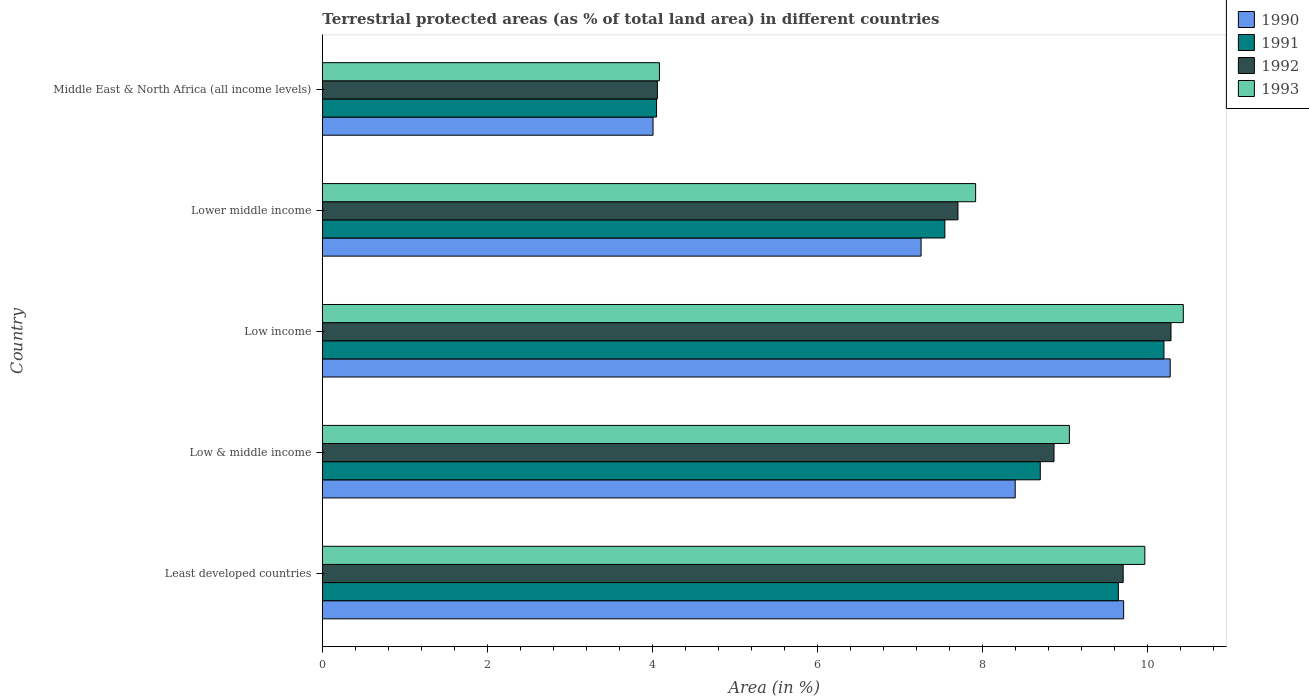How many groups of bars are there?
Provide a short and direct response. 5. Are the number of bars on each tick of the Y-axis equal?
Provide a succinct answer. Yes. What is the label of the 4th group of bars from the top?
Ensure brevity in your answer.  Low & middle income. In how many cases, is the number of bars for a given country not equal to the number of legend labels?
Make the answer very short. 0. What is the percentage of terrestrial protected land in 1992 in Middle East & North Africa (all income levels)?
Ensure brevity in your answer.  4.06. Across all countries, what is the maximum percentage of terrestrial protected land in 1990?
Your response must be concise. 10.27. Across all countries, what is the minimum percentage of terrestrial protected land in 1990?
Provide a succinct answer. 4.01. In which country was the percentage of terrestrial protected land in 1992 maximum?
Offer a very short reply. Low income. In which country was the percentage of terrestrial protected land in 1991 minimum?
Your answer should be compact. Middle East & North Africa (all income levels). What is the total percentage of terrestrial protected land in 1991 in the graph?
Ensure brevity in your answer.  40.14. What is the difference between the percentage of terrestrial protected land in 1990 in Least developed countries and that in Middle East & North Africa (all income levels)?
Make the answer very short. 5.7. What is the difference between the percentage of terrestrial protected land in 1992 in Middle East & North Africa (all income levels) and the percentage of terrestrial protected land in 1993 in Low income?
Give a very brief answer. -6.37. What is the average percentage of terrestrial protected land in 1993 per country?
Your response must be concise. 8.29. What is the difference between the percentage of terrestrial protected land in 1991 and percentage of terrestrial protected land in 1990 in Middle East & North Africa (all income levels)?
Your response must be concise. 0.04. In how many countries, is the percentage of terrestrial protected land in 1990 greater than 4.8 %?
Keep it short and to the point. 4. What is the ratio of the percentage of terrestrial protected land in 1990 in Least developed countries to that in Middle East & North Africa (all income levels)?
Provide a short and direct response. 2.42. Is the difference between the percentage of terrestrial protected land in 1991 in Low income and Middle East & North Africa (all income levels) greater than the difference between the percentage of terrestrial protected land in 1990 in Low income and Middle East & North Africa (all income levels)?
Make the answer very short. No. What is the difference between the highest and the second highest percentage of terrestrial protected land in 1990?
Offer a very short reply. 0.56. What is the difference between the highest and the lowest percentage of terrestrial protected land in 1991?
Your answer should be compact. 6.15. Is the sum of the percentage of terrestrial protected land in 1993 in Low & middle income and Low income greater than the maximum percentage of terrestrial protected land in 1991 across all countries?
Make the answer very short. Yes. What does the 1st bar from the top in Low income represents?
Your response must be concise. 1993. What does the 3rd bar from the bottom in Low & middle income represents?
Offer a very short reply. 1992. Is it the case that in every country, the sum of the percentage of terrestrial protected land in 1993 and percentage of terrestrial protected land in 1990 is greater than the percentage of terrestrial protected land in 1991?
Offer a very short reply. Yes. How many bars are there?
Make the answer very short. 20. Are all the bars in the graph horizontal?
Make the answer very short. Yes. What is the difference between two consecutive major ticks on the X-axis?
Give a very brief answer. 2. Does the graph contain any zero values?
Ensure brevity in your answer.  No. Where does the legend appear in the graph?
Keep it short and to the point. Top right. How are the legend labels stacked?
Offer a very short reply. Vertical. What is the title of the graph?
Make the answer very short. Terrestrial protected areas (as % of total land area) in different countries. What is the label or title of the X-axis?
Provide a short and direct response. Area (in %). What is the label or title of the Y-axis?
Make the answer very short. Country. What is the Area (in %) of 1990 in Least developed countries?
Make the answer very short. 9.71. What is the Area (in %) of 1991 in Least developed countries?
Provide a succinct answer. 9.65. What is the Area (in %) in 1992 in Least developed countries?
Your answer should be very brief. 9.7. What is the Area (in %) of 1993 in Least developed countries?
Keep it short and to the point. 9.97. What is the Area (in %) of 1990 in Low & middle income?
Your answer should be compact. 8.4. What is the Area (in %) of 1991 in Low & middle income?
Give a very brief answer. 8.7. What is the Area (in %) in 1992 in Low & middle income?
Provide a short and direct response. 8.87. What is the Area (in %) in 1993 in Low & middle income?
Your response must be concise. 9.05. What is the Area (in %) in 1990 in Low income?
Offer a terse response. 10.27. What is the Area (in %) in 1991 in Low income?
Your answer should be very brief. 10.2. What is the Area (in %) in 1992 in Low income?
Ensure brevity in your answer.  10.28. What is the Area (in %) in 1993 in Low income?
Your response must be concise. 10.43. What is the Area (in %) of 1990 in Lower middle income?
Your answer should be compact. 7.26. What is the Area (in %) of 1991 in Lower middle income?
Give a very brief answer. 7.54. What is the Area (in %) in 1992 in Lower middle income?
Your response must be concise. 7.7. What is the Area (in %) of 1993 in Lower middle income?
Make the answer very short. 7.92. What is the Area (in %) of 1990 in Middle East & North Africa (all income levels)?
Provide a succinct answer. 4.01. What is the Area (in %) of 1991 in Middle East & North Africa (all income levels)?
Offer a very short reply. 4.05. What is the Area (in %) of 1992 in Middle East & North Africa (all income levels)?
Make the answer very short. 4.06. What is the Area (in %) of 1993 in Middle East & North Africa (all income levels)?
Make the answer very short. 4.08. Across all countries, what is the maximum Area (in %) in 1990?
Your response must be concise. 10.27. Across all countries, what is the maximum Area (in %) of 1991?
Your answer should be very brief. 10.2. Across all countries, what is the maximum Area (in %) in 1992?
Provide a succinct answer. 10.28. Across all countries, what is the maximum Area (in %) in 1993?
Give a very brief answer. 10.43. Across all countries, what is the minimum Area (in %) of 1990?
Offer a very short reply. 4.01. Across all countries, what is the minimum Area (in %) in 1991?
Your answer should be very brief. 4.05. Across all countries, what is the minimum Area (in %) in 1992?
Offer a terse response. 4.06. Across all countries, what is the minimum Area (in %) in 1993?
Keep it short and to the point. 4.08. What is the total Area (in %) of 1990 in the graph?
Offer a very short reply. 39.64. What is the total Area (in %) of 1991 in the graph?
Your response must be concise. 40.14. What is the total Area (in %) of 1992 in the graph?
Make the answer very short. 40.62. What is the total Area (in %) of 1993 in the graph?
Your response must be concise. 41.45. What is the difference between the Area (in %) of 1990 in Least developed countries and that in Low & middle income?
Provide a succinct answer. 1.31. What is the difference between the Area (in %) of 1991 in Least developed countries and that in Low & middle income?
Keep it short and to the point. 0.95. What is the difference between the Area (in %) of 1992 in Least developed countries and that in Low & middle income?
Offer a terse response. 0.84. What is the difference between the Area (in %) in 1993 in Least developed countries and that in Low & middle income?
Your answer should be compact. 0.91. What is the difference between the Area (in %) in 1990 in Least developed countries and that in Low income?
Your answer should be very brief. -0.56. What is the difference between the Area (in %) in 1991 in Least developed countries and that in Low income?
Offer a very short reply. -0.55. What is the difference between the Area (in %) of 1992 in Least developed countries and that in Low income?
Provide a succinct answer. -0.58. What is the difference between the Area (in %) in 1993 in Least developed countries and that in Low income?
Provide a succinct answer. -0.47. What is the difference between the Area (in %) of 1990 in Least developed countries and that in Lower middle income?
Provide a short and direct response. 2.45. What is the difference between the Area (in %) of 1991 in Least developed countries and that in Lower middle income?
Keep it short and to the point. 2.1. What is the difference between the Area (in %) in 1992 in Least developed countries and that in Lower middle income?
Your response must be concise. 2. What is the difference between the Area (in %) of 1993 in Least developed countries and that in Lower middle income?
Provide a short and direct response. 2.05. What is the difference between the Area (in %) in 1990 in Least developed countries and that in Middle East & North Africa (all income levels)?
Give a very brief answer. 5.7. What is the difference between the Area (in %) of 1991 in Least developed countries and that in Middle East & North Africa (all income levels)?
Keep it short and to the point. 5.6. What is the difference between the Area (in %) of 1992 in Least developed countries and that in Middle East & North Africa (all income levels)?
Offer a terse response. 5.64. What is the difference between the Area (in %) in 1993 in Least developed countries and that in Middle East & North Africa (all income levels)?
Keep it short and to the point. 5.88. What is the difference between the Area (in %) of 1990 in Low & middle income and that in Low income?
Your answer should be very brief. -1.88. What is the difference between the Area (in %) in 1991 in Low & middle income and that in Low income?
Make the answer very short. -1.5. What is the difference between the Area (in %) of 1992 in Low & middle income and that in Low income?
Provide a short and direct response. -1.42. What is the difference between the Area (in %) of 1993 in Low & middle income and that in Low income?
Keep it short and to the point. -1.38. What is the difference between the Area (in %) of 1990 in Low & middle income and that in Lower middle income?
Make the answer very short. 1.14. What is the difference between the Area (in %) in 1991 in Low & middle income and that in Lower middle income?
Offer a terse response. 1.16. What is the difference between the Area (in %) in 1992 in Low & middle income and that in Lower middle income?
Keep it short and to the point. 1.16. What is the difference between the Area (in %) of 1993 in Low & middle income and that in Lower middle income?
Offer a very short reply. 1.14. What is the difference between the Area (in %) in 1990 in Low & middle income and that in Middle East & North Africa (all income levels)?
Your response must be concise. 4.39. What is the difference between the Area (in %) in 1991 in Low & middle income and that in Middle East & North Africa (all income levels)?
Your answer should be compact. 4.65. What is the difference between the Area (in %) in 1992 in Low & middle income and that in Middle East & North Africa (all income levels)?
Offer a terse response. 4.81. What is the difference between the Area (in %) in 1993 in Low & middle income and that in Middle East & North Africa (all income levels)?
Offer a terse response. 4.97. What is the difference between the Area (in %) of 1990 in Low income and that in Lower middle income?
Offer a terse response. 3.02. What is the difference between the Area (in %) in 1991 in Low income and that in Lower middle income?
Ensure brevity in your answer.  2.65. What is the difference between the Area (in %) in 1992 in Low income and that in Lower middle income?
Offer a terse response. 2.58. What is the difference between the Area (in %) of 1993 in Low income and that in Lower middle income?
Provide a succinct answer. 2.52. What is the difference between the Area (in %) of 1990 in Low income and that in Middle East & North Africa (all income levels)?
Offer a very short reply. 6.27. What is the difference between the Area (in %) in 1991 in Low income and that in Middle East & North Africa (all income levels)?
Your response must be concise. 6.15. What is the difference between the Area (in %) of 1992 in Low income and that in Middle East & North Africa (all income levels)?
Make the answer very short. 6.22. What is the difference between the Area (in %) in 1993 in Low income and that in Middle East & North Africa (all income levels)?
Ensure brevity in your answer.  6.35. What is the difference between the Area (in %) of 1990 in Lower middle income and that in Middle East & North Africa (all income levels)?
Provide a short and direct response. 3.25. What is the difference between the Area (in %) of 1991 in Lower middle income and that in Middle East & North Africa (all income levels)?
Ensure brevity in your answer.  3.49. What is the difference between the Area (in %) in 1992 in Lower middle income and that in Middle East & North Africa (all income levels)?
Your answer should be very brief. 3.64. What is the difference between the Area (in %) in 1993 in Lower middle income and that in Middle East & North Africa (all income levels)?
Offer a very short reply. 3.83. What is the difference between the Area (in %) in 1990 in Least developed countries and the Area (in %) in 1991 in Low & middle income?
Your answer should be very brief. 1.01. What is the difference between the Area (in %) in 1990 in Least developed countries and the Area (in %) in 1992 in Low & middle income?
Your answer should be compact. 0.84. What is the difference between the Area (in %) of 1990 in Least developed countries and the Area (in %) of 1993 in Low & middle income?
Provide a succinct answer. 0.66. What is the difference between the Area (in %) in 1991 in Least developed countries and the Area (in %) in 1992 in Low & middle income?
Provide a short and direct response. 0.78. What is the difference between the Area (in %) in 1991 in Least developed countries and the Area (in %) in 1993 in Low & middle income?
Your response must be concise. 0.59. What is the difference between the Area (in %) in 1992 in Least developed countries and the Area (in %) in 1993 in Low & middle income?
Make the answer very short. 0.65. What is the difference between the Area (in %) in 1990 in Least developed countries and the Area (in %) in 1991 in Low income?
Provide a short and direct response. -0.49. What is the difference between the Area (in %) in 1990 in Least developed countries and the Area (in %) in 1992 in Low income?
Provide a succinct answer. -0.57. What is the difference between the Area (in %) in 1990 in Least developed countries and the Area (in %) in 1993 in Low income?
Your answer should be very brief. -0.72. What is the difference between the Area (in %) in 1991 in Least developed countries and the Area (in %) in 1992 in Low income?
Your answer should be very brief. -0.64. What is the difference between the Area (in %) in 1991 in Least developed countries and the Area (in %) in 1993 in Low income?
Give a very brief answer. -0.79. What is the difference between the Area (in %) of 1992 in Least developed countries and the Area (in %) of 1993 in Low income?
Offer a terse response. -0.73. What is the difference between the Area (in %) of 1990 in Least developed countries and the Area (in %) of 1991 in Lower middle income?
Your answer should be very brief. 2.17. What is the difference between the Area (in %) of 1990 in Least developed countries and the Area (in %) of 1992 in Lower middle income?
Provide a short and direct response. 2.01. What is the difference between the Area (in %) in 1990 in Least developed countries and the Area (in %) in 1993 in Lower middle income?
Give a very brief answer. 1.79. What is the difference between the Area (in %) in 1991 in Least developed countries and the Area (in %) in 1992 in Lower middle income?
Your response must be concise. 1.94. What is the difference between the Area (in %) of 1991 in Least developed countries and the Area (in %) of 1993 in Lower middle income?
Your answer should be very brief. 1.73. What is the difference between the Area (in %) of 1992 in Least developed countries and the Area (in %) of 1993 in Lower middle income?
Offer a terse response. 1.79. What is the difference between the Area (in %) of 1990 in Least developed countries and the Area (in %) of 1991 in Middle East & North Africa (all income levels)?
Your answer should be very brief. 5.66. What is the difference between the Area (in %) in 1990 in Least developed countries and the Area (in %) in 1992 in Middle East & North Africa (all income levels)?
Ensure brevity in your answer.  5.65. What is the difference between the Area (in %) in 1990 in Least developed countries and the Area (in %) in 1993 in Middle East & North Africa (all income levels)?
Offer a terse response. 5.63. What is the difference between the Area (in %) in 1991 in Least developed countries and the Area (in %) in 1992 in Middle East & North Africa (all income levels)?
Offer a terse response. 5.59. What is the difference between the Area (in %) of 1991 in Least developed countries and the Area (in %) of 1993 in Middle East & North Africa (all income levels)?
Your answer should be compact. 5.56. What is the difference between the Area (in %) in 1992 in Least developed countries and the Area (in %) in 1993 in Middle East & North Africa (all income levels)?
Provide a short and direct response. 5.62. What is the difference between the Area (in %) of 1990 in Low & middle income and the Area (in %) of 1991 in Low income?
Ensure brevity in your answer.  -1.8. What is the difference between the Area (in %) of 1990 in Low & middle income and the Area (in %) of 1992 in Low income?
Your answer should be very brief. -1.89. What is the difference between the Area (in %) in 1990 in Low & middle income and the Area (in %) in 1993 in Low income?
Provide a succinct answer. -2.04. What is the difference between the Area (in %) of 1991 in Low & middle income and the Area (in %) of 1992 in Low income?
Offer a terse response. -1.58. What is the difference between the Area (in %) in 1991 in Low & middle income and the Area (in %) in 1993 in Low income?
Keep it short and to the point. -1.73. What is the difference between the Area (in %) of 1992 in Low & middle income and the Area (in %) of 1993 in Low income?
Your answer should be compact. -1.57. What is the difference between the Area (in %) in 1990 in Low & middle income and the Area (in %) in 1991 in Lower middle income?
Keep it short and to the point. 0.85. What is the difference between the Area (in %) in 1990 in Low & middle income and the Area (in %) in 1992 in Lower middle income?
Offer a very short reply. 0.69. What is the difference between the Area (in %) in 1990 in Low & middle income and the Area (in %) in 1993 in Lower middle income?
Provide a short and direct response. 0.48. What is the difference between the Area (in %) in 1991 in Low & middle income and the Area (in %) in 1992 in Lower middle income?
Your answer should be compact. 1. What is the difference between the Area (in %) in 1991 in Low & middle income and the Area (in %) in 1993 in Lower middle income?
Provide a succinct answer. 0.78. What is the difference between the Area (in %) in 1992 in Low & middle income and the Area (in %) in 1993 in Lower middle income?
Ensure brevity in your answer.  0.95. What is the difference between the Area (in %) of 1990 in Low & middle income and the Area (in %) of 1991 in Middle East & North Africa (all income levels)?
Offer a very short reply. 4.35. What is the difference between the Area (in %) of 1990 in Low & middle income and the Area (in %) of 1992 in Middle East & North Africa (all income levels)?
Offer a very short reply. 4.34. What is the difference between the Area (in %) in 1990 in Low & middle income and the Area (in %) in 1993 in Middle East & North Africa (all income levels)?
Your answer should be compact. 4.31. What is the difference between the Area (in %) in 1991 in Low & middle income and the Area (in %) in 1992 in Middle East & North Africa (all income levels)?
Ensure brevity in your answer.  4.64. What is the difference between the Area (in %) of 1991 in Low & middle income and the Area (in %) of 1993 in Middle East & North Africa (all income levels)?
Keep it short and to the point. 4.62. What is the difference between the Area (in %) of 1992 in Low & middle income and the Area (in %) of 1993 in Middle East & North Africa (all income levels)?
Ensure brevity in your answer.  4.78. What is the difference between the Area (in %) in 1990 in Low income and the Area (in %) in 1991 in Lower middle income?
Give a very brief answer. 2.73. What is the difference between the Area (in %) in 1990 in Low income and the Area (in %) in 1992 in Lower middle income?
Your response must be concise. 2.57. What is the difference between the Area (in %) of 1990 in Low income and the Area (in %) of 1993 in Lower middle income?
Give a very brief answer. 2.36. What is the difference between the Area (in %) in 1991 in Low income and the Area (in %) in 1992 in Lower middle income?
Your answer should be compact. 2.5. What is the difference between the Area (in %) in 1991 in Low income and the Area (in %) in 1993 in Lower middle income?
Your answer should be very brief. 2.28. What is the difference between the Area (in %) of 1992 in Low income and the Area (in %) of 1993 in Lower middle income?
Your response must be concise. 2.37. What is the difference between the Area (in %) of 1990 in Low income and the Area (in %) of 1991 in Middle East & North Africa (all income levels)?
Provide a succinct answer. 6.22. What is the difference between the Area (in %) in 1990 in Low income and the Area (in %) in 1992 in Middle East & North Africa (all income levels)?
Your answer should be very brief. 6.21. What is the difference between the Area (in %) in 1990 in Low income and the Area (in %) in 1993 in Middle East & North Africa (all income levels)?
Your answer should be very brief. 6.19. What is the difference between the Area (in %) of 1991 in Low income and the Area (in %) of 1992 in Middle East & North Africa (all income levels)?
Give a very brief answer. 6.14. What is the difference between the Area (in %) in 1991 in Low income and the Area (in %) in 1993 in Middle East & North Africa (all income levels)?
Give a very brief answer. 6.11. What is the difference between the Area (in %) in 1992 in Low income and the Area (in %) in 1993 in Middle East & North Africa (all income levels)?
Make the answer very short. 6.2. What is the difference between the Area (in %) of 1990 in Lower middle income and the Area (in %) of 1991 in Middle East & North Africa (all income levels)?
Provide a succinct answer. 3.21. What is the difference between the Area (in %) of 1990 in Lower middle income and the Area (in %) of 1992 in Middle East & North Africa (all income levels)?
Your answer should be compact. 3.2. What is the difference between the Area (in %) of 1990 in Lower middle income and the Area (in %) of 1993 in Middle East & North Africa (all income levels)?
Your response must be concise. 3.17. What is the difference between the Area (in %) in 1991 in Lower middle income and the Area (in %) in 1992 in Middle East & North Africa (all income levels)?
Ensure brevity in your answer.  3.48. What is the difference between the Area (in %) in 1991 in Lower middle income and the Area (in %) in 1993 in Middle East & North Africa (all income levels)?
Keep it short and to the point. 3.46. What is the difference between the Area (in %) in 1992 in Lower middle income and the Area (in %) in 1993 in Middle East & North Africa (all income levels)?
Ensure brevity in your answer.  3.62. What is the average Area (in %) of 1990 per country?
Provide a short and direct response. 7.93. What is the average Area (in %) of 1991 per country?
Provide a short and direct response. 8.03. What is the average Area (in %) of 1992 per country?
Your response must be concise. 8.12. What is the average Area (in %) in 1993 per country?
Your answer should be compact. 8.29. What is the difference between the Area (in %) in 1990 and Area (in %) in 1991 in Least developed countries?
Offer a terse response. 0.06. What is the difference between the Area (in %) of 1990 and Area (in %) of 1992 in Least developed countries?
Provide a short and direct response. 0.01. What is the difference between the Area (in %) in 1990 and Area (in %) in 1993 in Least developed countries?
Offer a terse response. -0.26. What is the difference between the Area (in %) in 1991 and Area (in %) in 1992 in Least developed countries?
Your answer should be compact. -0.06. What is the difference between the Area (in %) of 1991 and Area (in %) of 1993 in Least developed countries?
Offer a terse response. -0.32. What is the difference between the Area (in %) in 1992 and Area (in %) in 1993 in Least developed countries?
Ensure brevity in your answer.  -0.26. What is the difference between the Area (in %) of 1990 and Area (in %) of 1991 in Low & middle income?
Make the answer very short. -0.3. What is the difference between the Area (in %) of 1990 and Area (in %) of 1992 in Low & middle income?
Provide a succinct answer. -0.47. What is the difference between the Area (in %) in 1990 and Area (in %) in 1993 in Low & middle income?
Your response must be concise. -0.66. What is the difference between the Area (in %) of 1991 and Area (in %) of 1992 in Low & middle income?
Keep it short and to the point. -0.17. What is the difference between the Area (in %) in 1991 and Area (in %) in 1993 in Low & middle income?
Provide a short and direct response. -0.35. What is the difference between the Area (in %) in 1992 and Area (in %) in 1993 in Low & middle income?
Give a very brief answer. -0.19. What is the difference between the Area (in %) in 1990 and Area (in %) in 1991 in Low income?
Your answer should be very brief. 0.08. What is the difference between the Area (in %) of 1990 and Area (in %) of 1992 in Low income?
Ensure brevity in your answer.  -0.01. What is the difference between the Area (in %) of 1990 and Area (in %) of 1993 in Low income?
Give a very brief answer. -0.16. What is the difference between the Area (in %) of 1991 and Area (in %) of 1992 in Low income?
Offer a very short reply. -0.09. What is the difference between the Area (in %) in 1991 and Area (in %) in 1993 in Low income?
Offer a very short reply. -0.23. What is the difference between the Area (in %) in 1992 and Area (in %) in 1993 in Low income?
Give a very brief answer. -0.15. What is the difference between the Area (in %) of 1990 and Area (in %) of 1991 in Lower middle income?
Your answer should be compact. -0.29. What is the difference between the Area (in %) of 1990 and Area (in %) of 1992 in Lower middle income?
Your response must be concise. -0.45. What is the difference between the Area (in %) in 1990 and Area (in %) in 1993 in Lower middle income?
Provide a succinct answer. -0.66. What is the difference between the Area (in %) in 1991 and Area (in %) in 1992 in Lower middle income?
Provide a short and direct response. -0.16. What is the difference between the Area (in %) of 1991 and Area (in %) of 1993 in Lower middle income?
Provide a short and direct response. -0.37. What is the difference between the Area (in %) in 1992 and Area (in %) in 1993 in Lower middle income?
Ensure brevity in your answer.  -0.21. What is the difference between the Area (in %) in 1990 and Area (in %) in 1991 in Middle East & North Africa (all income levels)?
Provide a short and direct response. -0.04. What is the difference between the Area (in %) in 1990 and Area (in %) in 1992 in Middle East & North Africa (all income levels)?
Give a very brief answer. -0.05. What is the difference between the Area (in %) in 1990 and Area (in %) in 1993 in Middle East & North Africa (all income levels)?
Your response must be concise. -0.08. What is the difference between the Area (in %) of 1991 and Area (in %) of 1992 in Middle East & North Africa (all income levels)?
Your answer should be very brief. -0.01. What is the difference between the Area (in %) in 1991 and Area (in %) in 1993 in Middle East & North Africa (all income levels)?
Provide a short and direct response. -0.03. What is the difference between the Area (in %) of 1992 and Area (in %) of 1993 in Middle East & North Africa (all income levels)?
Make the answer very short. -0.02. What is the ratio of the Area (in %) in 1990 in Least developed countries to that in Low & middle income?
Offer a terse response. 1.16. What is the ratio of the Area (in %) in 1991 in Least developed countries to that in Low & middle income?
Your answer should be very brief. 1.11. What is the ratio of the Area (in %) of 1992 in Least developed countries to that in Low & middle income?
Your answer should be compact. 1.09. What is the ratio of the Area (in %) of 1993 in Least developed countries to that in Low & middle income?
Your response must be concise. 1.1. What is the ratio of the Area (in %) of 1990 in Least developed countries to that in Low income?
Offer a very short reply. 0.95. What is the ratio of the Area (in %) in 1991 in Least developed countries to that in Low income?
Offer a terse response. 0.95. What is the ratio of the Area (in %) in 1992 in Least developed countries to that in Low income?
Offer a terse response. 0.94. What is the ratio of the Area (in %) in 1993 in Least developed countries to that in Low income?
Provide a short and direct response. 0.96. What is the ratio of the Area (in %) of 1990 in Least developed countries to that in Lower middle income?
Ensure brevity in your answer.  1.34. What is the ratio of the Area (in %) in 1991 in Least developed countries to that in Lower middle income?
Offer a terse response. 1.28. What is the ratio of the Area (in %) of 1992 in Least developed countries to that in Lower middle income?
Ensure brevity in your answer.  1.26. What is the ratio of the Area (in %) in 1993 in Least developed countries to that in Lower middle income?
Provide a succinct answer. 1.26. What is the ratio of the Area (in %) of 1990 in Least developed countries to that in Middle East & North Africa (all income levels)?
Provide a succinct answer. 2.42. What is the ratio of the Area (in %) of 1991 in Least developed countries to that in Middle East & North Africa (all income levels)?
Provide a succinct answer. 2.38. What is the ratio of the Area (in %) in 1992 in Least developed countries to that in Middle East & North Africa (all income levels)?
Your response must be concise. 2.39. What is the ratio of the Area (in %) of 1993 in Least developed countries to that in Middle East & North Africa (all income levels)?
Provide a short and direct response. 2.44. What is the ratio of the Area (in %) of 1990 in Low & middle income to that in Low income?
Provide a succinct answer. 0.82. What is the ratio of the Area (in %) in 1991 in Low & middle income to that in Low income?
Your response must be concise. 0.85. What is the ratio of the Area (in %) of 1992 in Low & middle income to that in Low income?
Give a very brief answer. 0.86. What is the ratio of the Area (in %) of 1993 in Low & middle income to that in Low income?
Keep it short and to the point. 0.87. What is the ratio of the Area (in %) of 1990 in Low & middle income to that in Lower middle income?
Your answer should be compact. 1.16. What is the ratio of the Area (in %) of 1991 in Low & middle income to that in Lower middle income?
Keep it short and to the point. 1.15. What is the ratio of the Area (in %) of 1992 in Low & middle income to that in Lower middle income?
Your answer should be very brief. 1.15. What is the ratio of the Area (in %) of 1993 in Low & middle income to that in Lower middle income?
Offer a very short reply. 1.14. What is the ratio of the Area (in %) of 1990 in Low & middle income to that in Middle East & North Africa (all income levels)?
Ensure brevity in your answer.  2.1. What is the ratio of the Area (in %) in 1991 in Low & middle income to that in Middle East & North Africa (all income levels)?
Your answer should be compact. 2.15. What is the ratio of the Area (in %) in 1992 in Low & middle income to that in Middle East & North Africa (all income levels)?
Offer a terse response. 2.18. What is the ratio of the Area (in %) of 1993 in Low & middle income to that in Middle East & North Africa (all income levels)?
Make the answer very short. 2.22. What is the ratio of the Area (in %) in 1990 in Low income to that in Lower middle income?
Ensure brevity in your answer.  1.42. What is the ratio of the Area (in %) of 1991 in Low income to that in Lower middle income?
Your answer should be compact. 1.35. What is the ratio of the Area (in %) in 1992 in Low income to that in Lower middle income?
Offer a terse response. 1.34. What is the ratio of the Area (in %) of 1993 in Low income to that in Lower middle income?
Ensure brevity in your answer.  1.32. What is the ratio of the Area (in %) in 1990 in Low income to that in Middle East & North Africa (all income levels)?
Keep it short and to the point. 2.56. What is the ratio of the Area (in %) of 1991 in Low income to that in Middle East & North Africa (all income levels)?
Provide a short and direct response. 2.52. What is the ratio of the Area (in %) in 1992 in Low income to that in Middle East & North Africa (all income levels)?
Keep it short and to the point. 2.53. What is the ratio of the Area (in %) in 1993 in Low income to that in Middle East & North Africa (all income levels)?
Provide a succinct answer. 2.55. What is the ratio of the Area (in %) of 1990 in Lower middle income to that in Middle East & North Africa (all income levels)?
Provide a short and direct response. 1.81. What is the ratio of the Area (in %) in 1991 in Lower middle income to that in Middle East & North Africa (all income levels)?
Make the answer very short. 1.86. What is the ratio of the Area (in %) of 1992 in Lower middle income to that in Middle East & North Africa (all income levels)?
Give a very brief answer. 1.9. What is the ratio of the Area (in %) in 1993 in Lower middle income to that in Middle East & North Africa (all income levels)?
Give a very brief answer. 1.94. What is the difference between the highest and the second highest Area (in %) in 1990?
Your answer should be compact. 0.56. What is the difference between the highest and the second highest Area (in %) of 1991?
Offer a very short reply. 0.55. What is the difference between the highest and the second highest Area (in %) of 1992?
Your response must be concise. 0.58. What is the difference between the highest and the second highest Area (in %) of 1993?
Your answer should be compact. 0.47. What is the difference between the highest and the lowest Area (in %) of 1990?
Keep it short and to the point. 6.27. What is the difference between the highest and the lowest Area (in %) of 1991?
Offer a terse response. 6.15. What is the difference between the highest and the lowest Area (in %) in 1992?
Make the answer very short. 6.22. What is the difference between the highest and the lowest Area (in %) of 1993?
Your answer should be very brief. 6.35. 